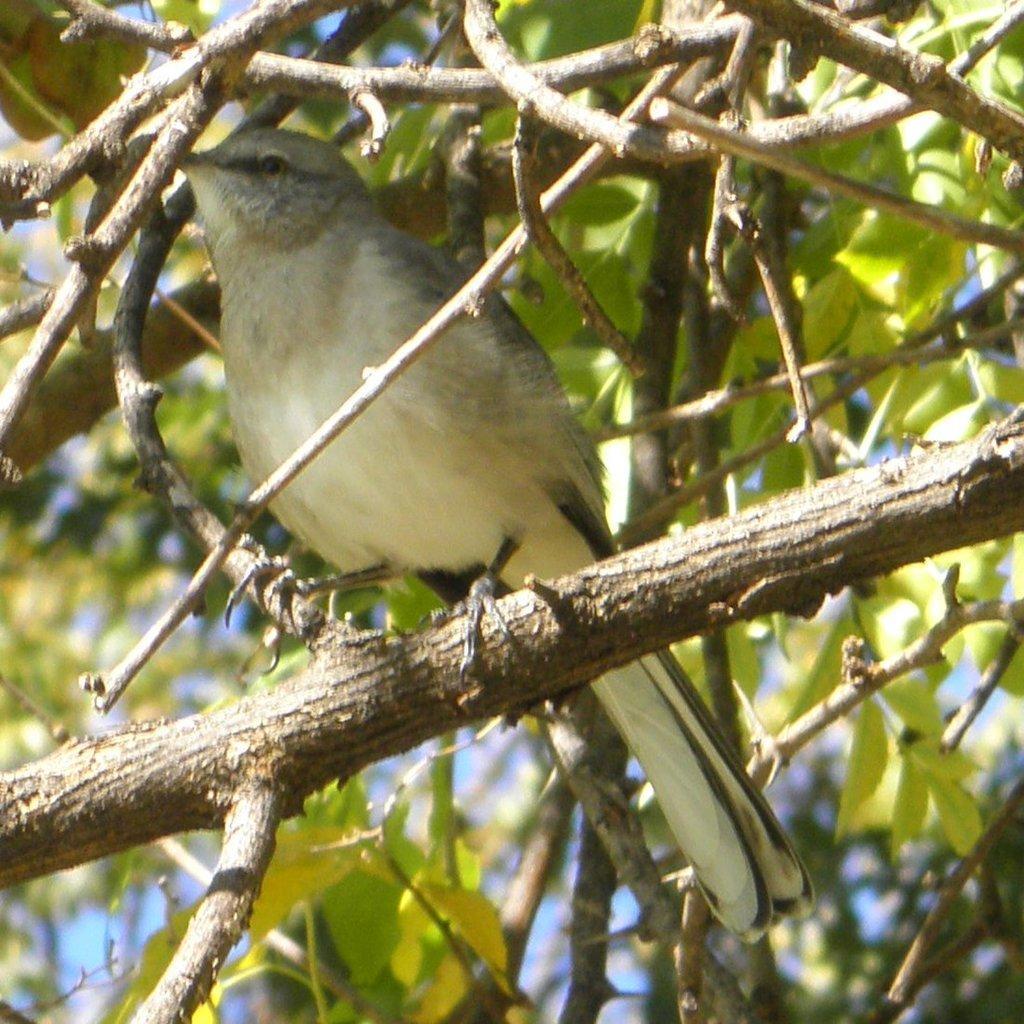In one or two sentences, can you explain what this image depicts? In this image I can see a bird which is cream, black and brown in color is on the tree branch. In the background I can see few trees and the sky. 